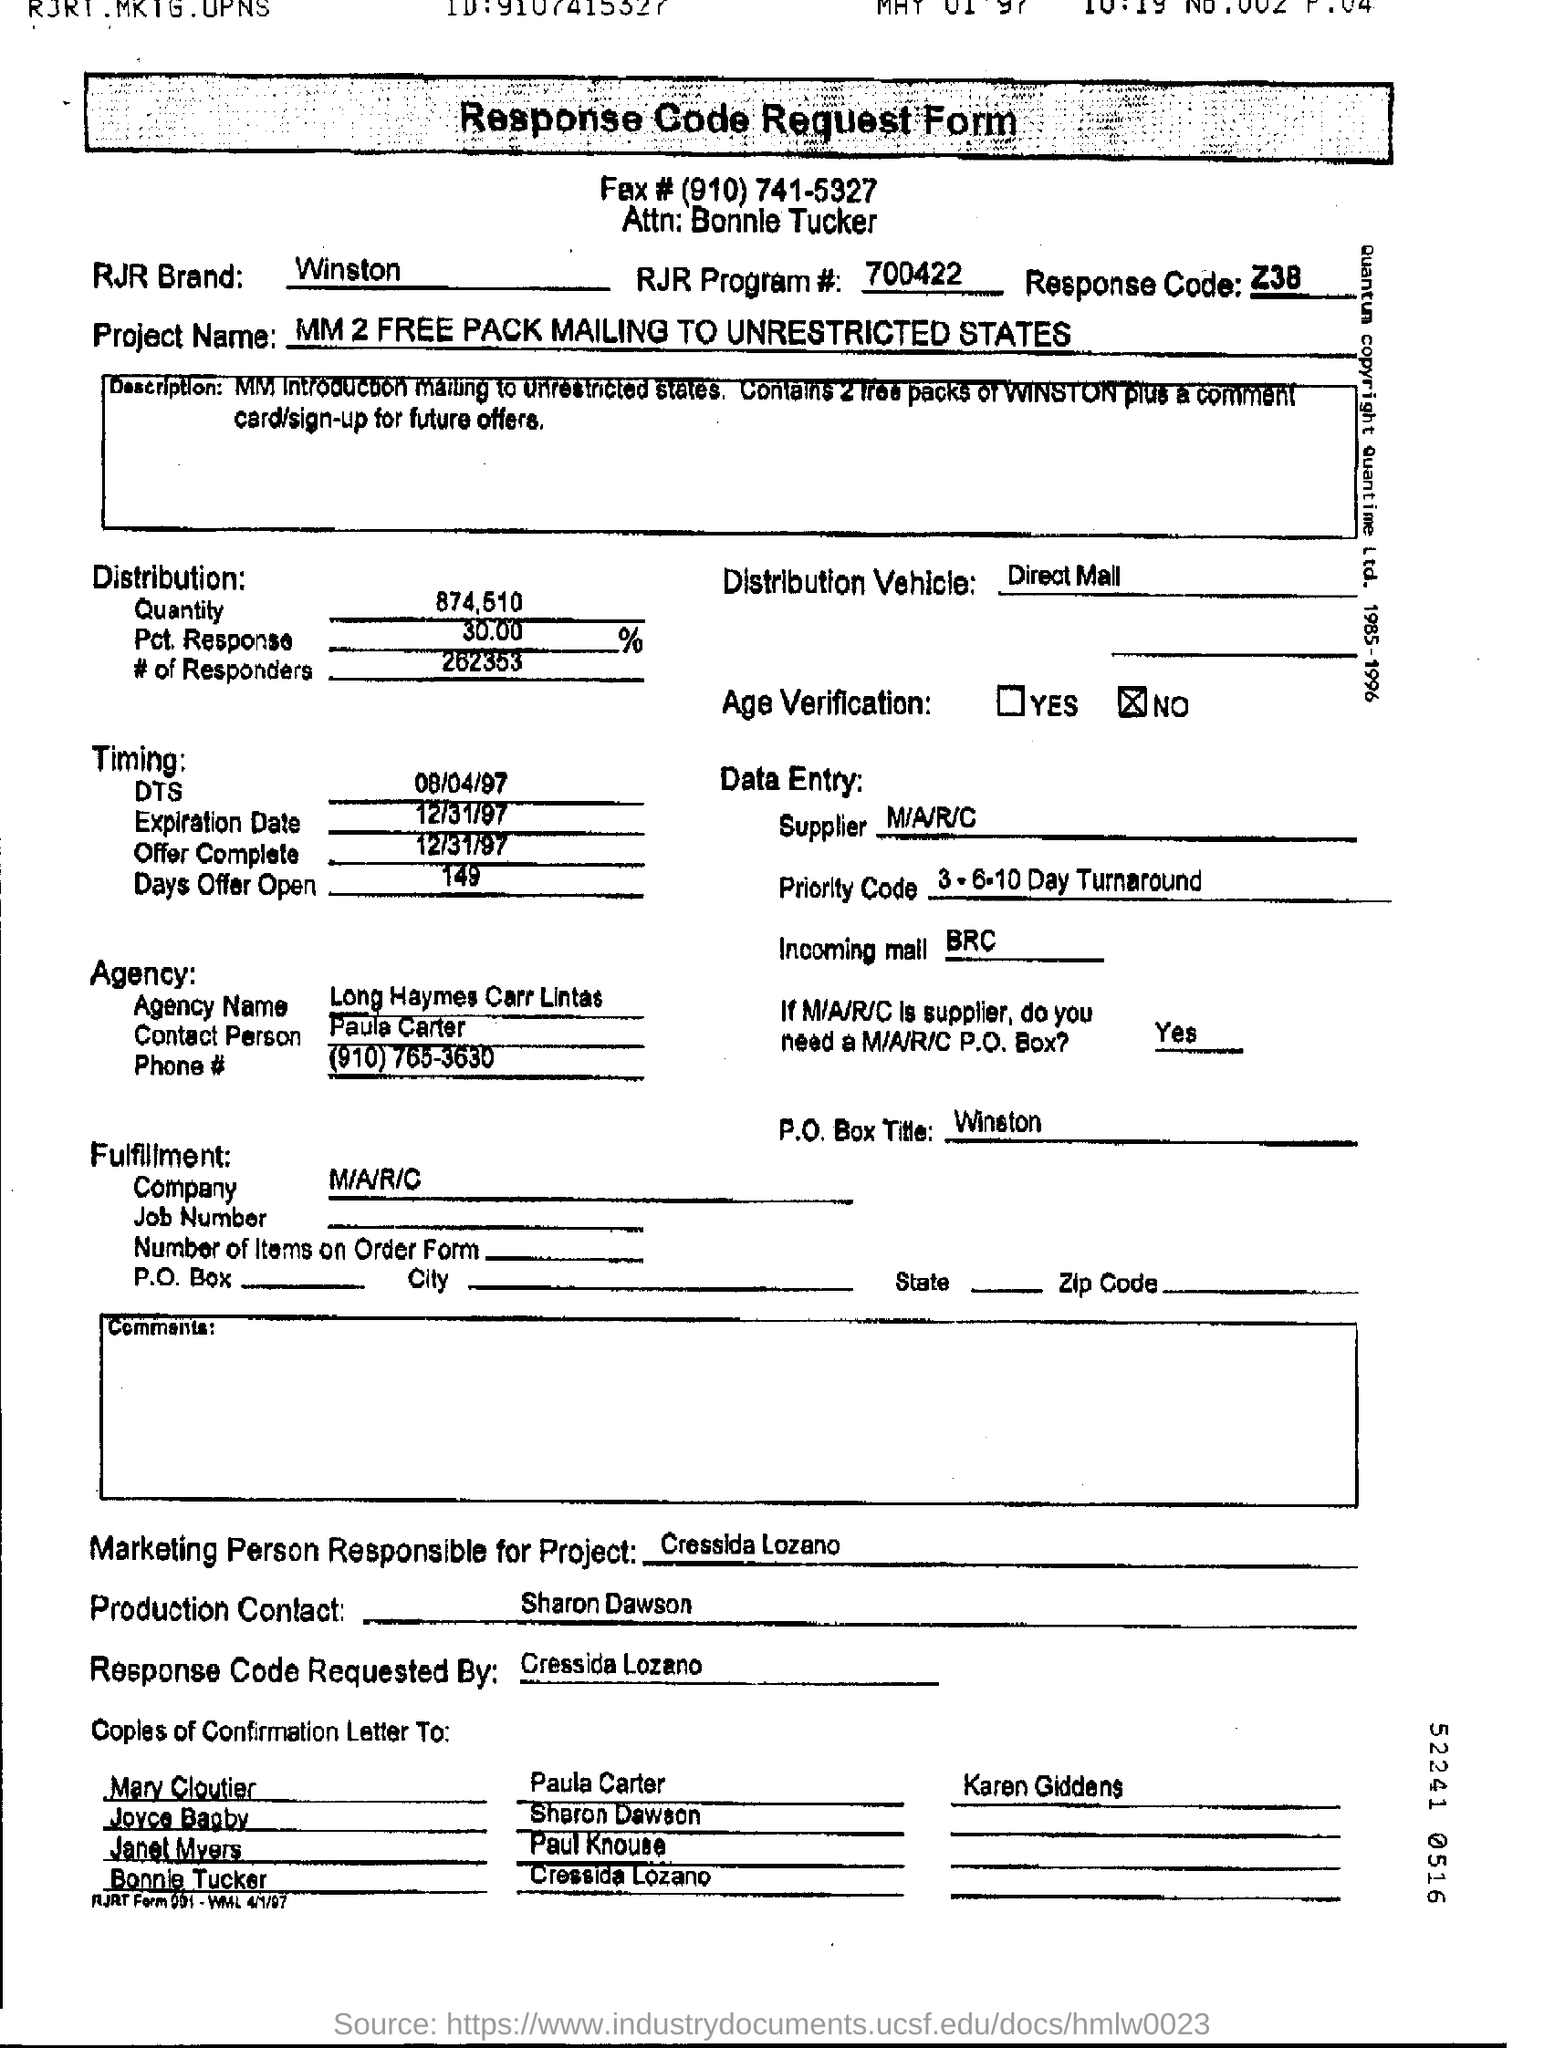List a handful of essential elements in this visual. RJR Brand is a company that produces Winston cigarettes. The response code was requested by Cressida Lozano. The distribution quantity is 874,510. 